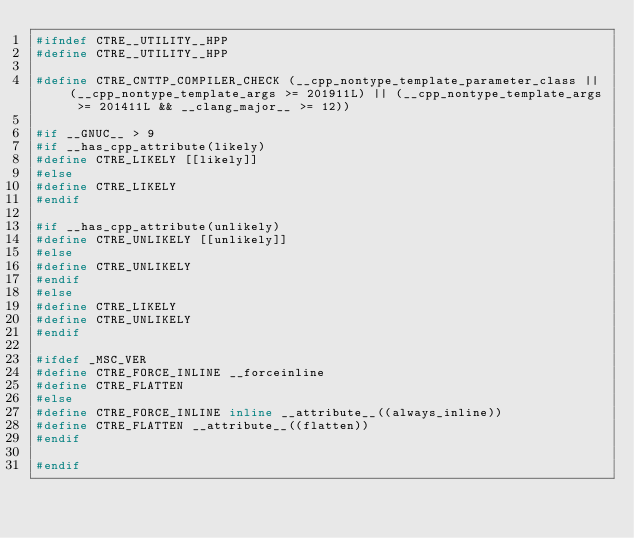Convert code to text. <code><loc_0><loc_0><loc_500><loc_500><_C++_>#ifndef CTRE__UTILITY__HPP
#define CTRE__UTILITY__HPP

#define CTRE_CNTTP_COMPILER_CHECK (__cpp_nontype_template_parameter_class || (__cpp_nontype_template_args >= 201911L) || (__cpp_nontype_template_args >= 201411L && __clang_major__ >= 12))

#if __GNUC__ > 9
#if __has_cpp_attribute(likely)
#define CTRE_LIKELY [[likely]]
#else
#define CTRE_LIKELY
#endif

#if __has_cpp_attribute(unlikely)
#define CTRE_UNLIKELY [[unlikely]]
#else
#define CTRE_UNLIKELY
#endif
#else
#define CTRE_LIKELY
#define CTRE_UNLIKELY
#endif

#ifdef _MSC_VER
#define CTRE_FORCE_INLINE __forceinline
#define CTRE_FLATTEN
#else
#define CTRE_FORCE_INLINE inline __attribute__((always_inline))
#define CTRE_FLATTEN __attribute__((flatten))
#endif

#endif
</code> 